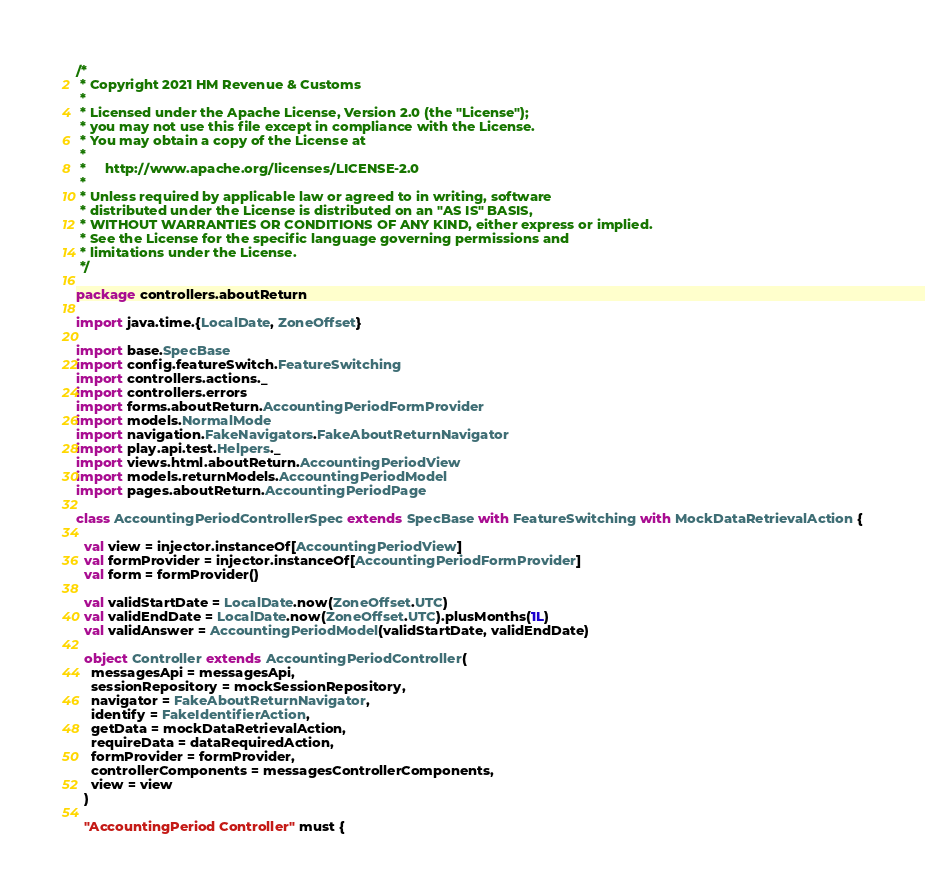<code> <loc_0><loc_0><loc_500><loc_500><_Scala_>/*
 * Copyright 2021 HM Revenue & Customs
 *
 * Licensed under the Apache License, Version 2.0 (the "License");
 * you may not use this file except in compliance with the License.
 * You may obtain a copy of the License at
 *
 *     http://www.apache.org/licenses/LICENSE-2.0
 *
 * Unless required by applicable law or agreed to in writing, software
 * distributed under the License is distributed on an "AS IS" BASIS,
 * WITHOUT WARRANTIES OR CONDITIONS OF ANY KIND, either express or implied.
 * See the License for the specific language governing permissions and
 * limitations under the License.
 */

package controllers.aboutReturn

import java.time.{LocalDate, ZoneOffset}

import base.SpecBase
import config.featureSwitch.FeatureSwitching
import controllers.actions._
import controllers.errors
import forms.aboutReturn.AccountingPeriodFormProvider
import models.NormalMode
import navigation.FakeNavigators.FakeAboutReturnNavigator
import play.api.test.Helpers._
import views.html.aboutReturn.AccountingPeriodView
import models.returnModels.AccountingPeriodModel
import pages.aboutReturn.AccountingPeriodPage

class AccountingPeriodControllerSpec extends SpecBase with FeatureSwitching with MockDataRetrievalAction {

  val view = injector.instanceOf[AccountingPeriodView]
  val formProvider = injector.instanceOf[AccountingPeriodFormProvider]
  val form = formProvider()

  val validStartDate = LocalDate.now(ZoneOffset.UTC)
  val validEndDate = LocalDate.now(ZoneOffset.UTC).plusMonths(1L)
  val validAnswer = AccountingPeriodModel(validStartDate, validEndDate)

  object Controller extends AccountingPeriodController(
    messagesApi = messagesApi,
    sessionRepository = mockSessionRepository,
    navigator = FakeAboutReturnNavigator,
    identify = FakeIdentifierAction,
    getData = mockDataRetrievalAction,
    requireData = dataRequiredAction,
    formProvider = formProvider,
    controllerComponents = messagesControllerComponents,
    view = view
  )

  "AccountingPeriod Controller" must {
</code> 